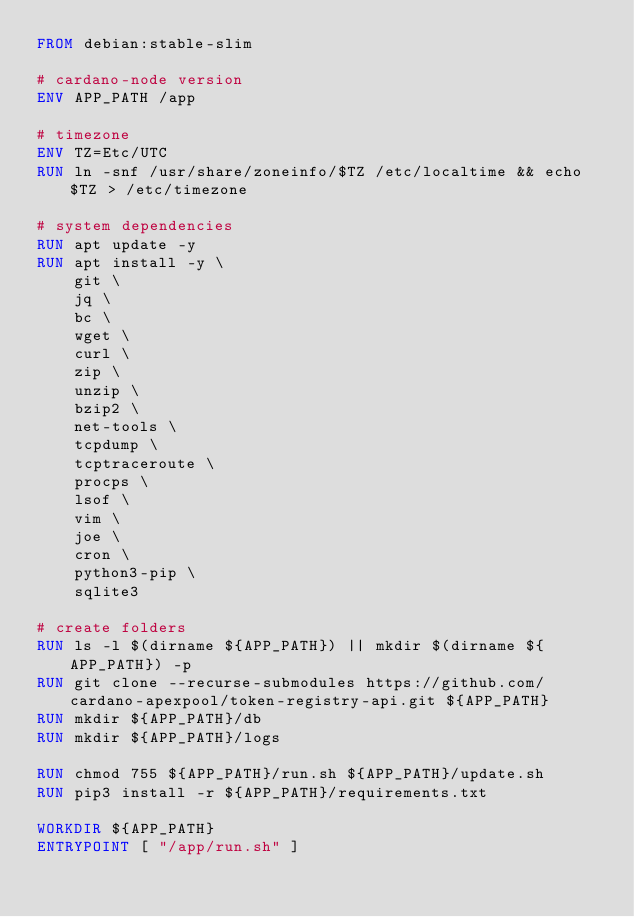<code> <loc_0><loc_0><loc_500><loc_500><_Dockerfile_>FROM debian:stable-slim

# cardano-node version
ENV APP_PATH /app

# timezone
ENV TZ=Etc/UTC
RUN ln -snf /usr/share/zoneinfo/$TZ /etc/localtime && echo $TZ > /etc/timezone

# system dependencies
RUN apt update -y
RUN apt install -y \
    git \
    jq \
    bc \
    wget \
    curl \
    zip \
    unzip \
    bzip2 \
    net-tools \
    tcpdump \
    tcptraceroute \
    procps \
    lsof \
    vim \
    joe \
    cron \
    python3-pip \
    sqlite3

# create folders
RUN ls -l $(dirname ${APP_PATH}) || mkdir $(dirname ${APP_PATH}) -p
RUN git clone --recurse-submodules https://github.com/cardano-apexpool/token-registry-api.git ${APP_PATH}
RUN mkdir ${APP_PATH}/db
RUN mkdir ${APP_PATH}/logs

RUN chmod 755 ${APP_PATH}/run.sh ${APP_PATH}/update.sh
RUN pip3 install -r ${APP_PATH}/requirements.txt

WORKDIR ${APP_PATH}
ENTRYPOINT [ "/app/run.sh" ]
</code> 